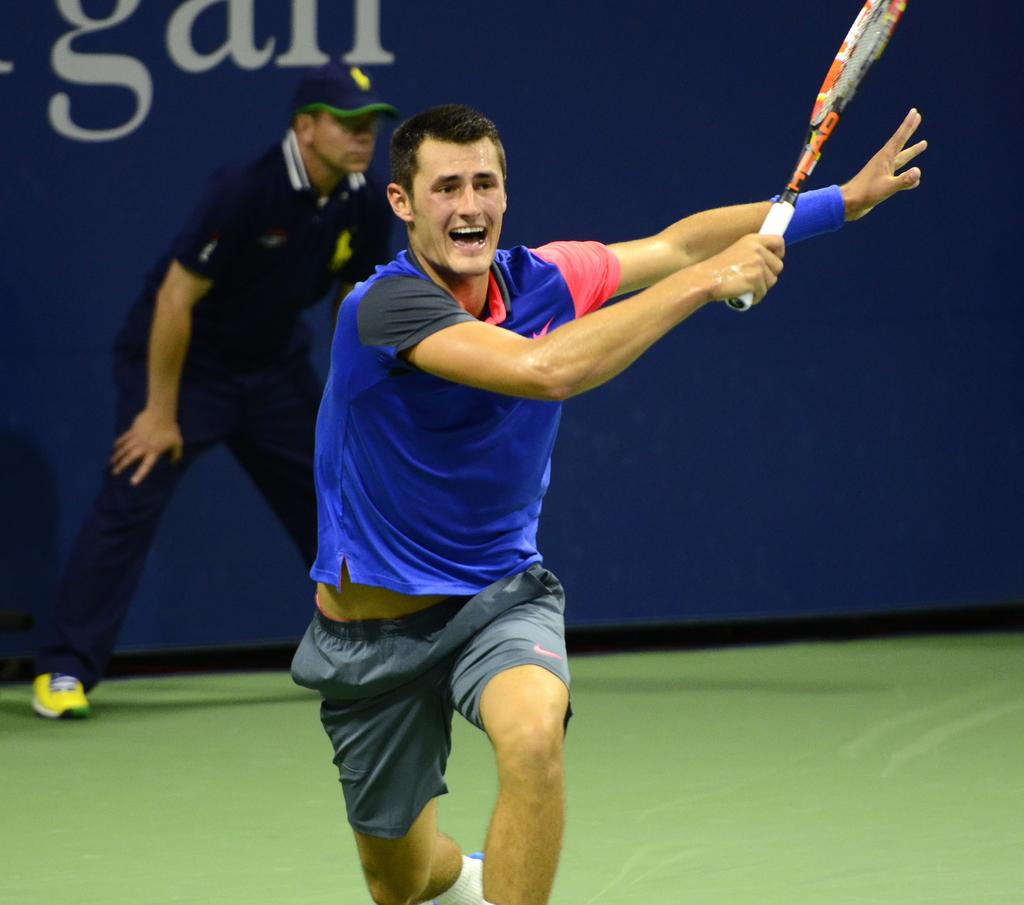What is the person in the image wearing? The person is wearing a blue shirt in the image. What activity is the person engaged in? The person is playing tennis. What color is the wall in the background of the image? The wall in the background of the image is blue. Can you describe any other people or objects in the image? There is a ball boy in the background of the image. Where is the baby in the image? There is no baby present in the image. What type of footwear is the mom wearing in the image? There is no mom or footwear mentioned in the image. 